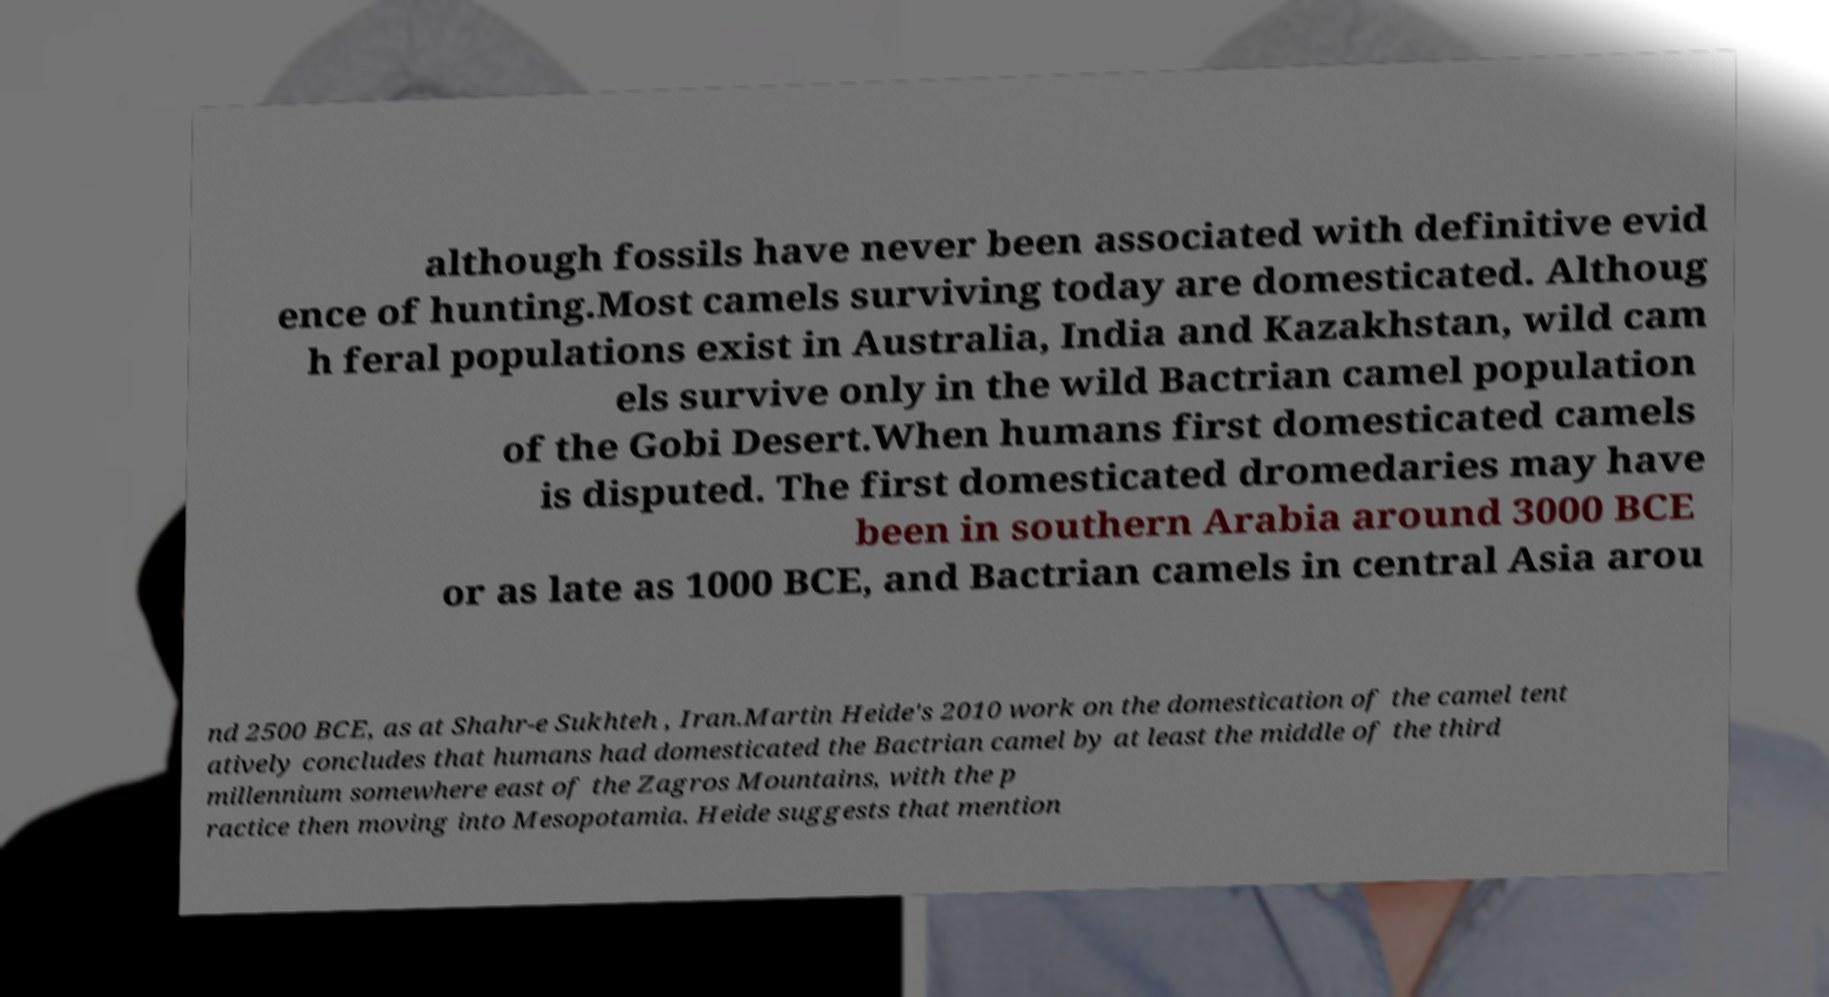I need the written content from this picture converted into text. Can you do that? although fossils have never been associated with definitive evid ence of hunting.Most camels surviving today are domesticated. Althoug h feral populations exist in Australia, India and Kazakhstan, wild cam els survive only in the wild Bactrian camel population of the Gobi Desert.When humans first domesticated camels is disputed. The first domesticated dromedaries may have been in southern Arabia around 3000 BCE or as late as 1000 BCE, and Bactrian camels in central Asia arou nd 2500 BCE, as at Shahr-e Sukhteh , Iran.Martin Heide's 2010 work on the domestication of the camel tent atively concludes that humans had domesticated the Bactrian camel by at least the middle of the third millennium somewhere east of the Zagros Mountains, with the p ractice then moving into Mesopotamia. Heide suggests that mention 